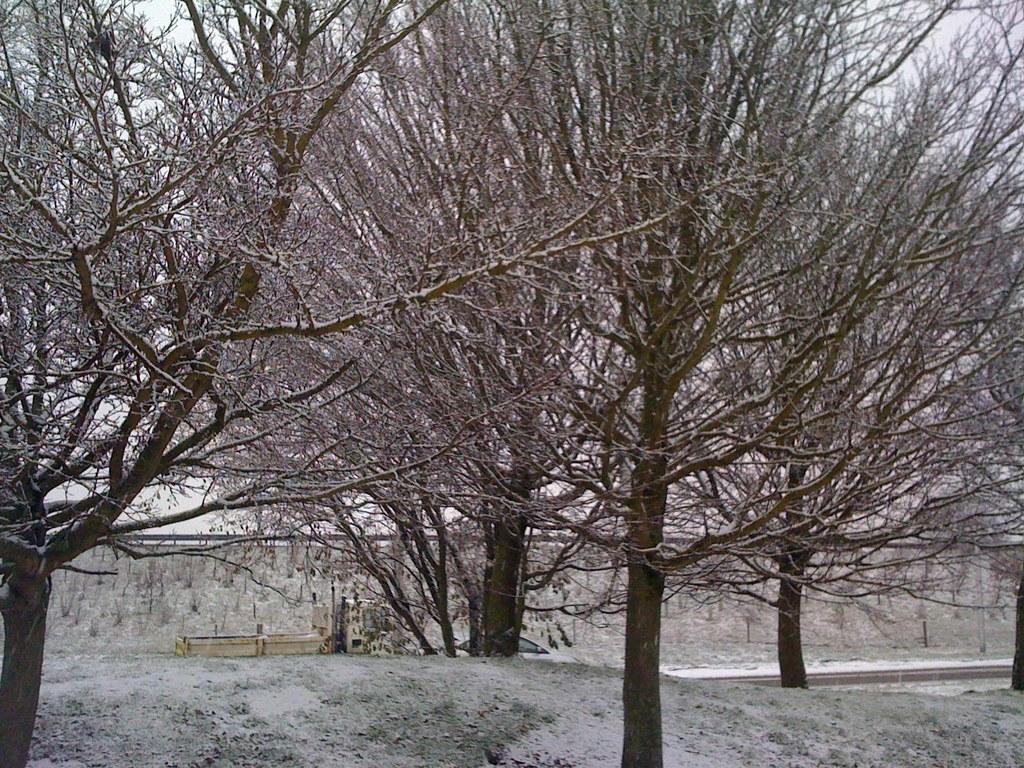In one or two sentences, can you explain what this image depicts? In this picture we can see bare trees. 